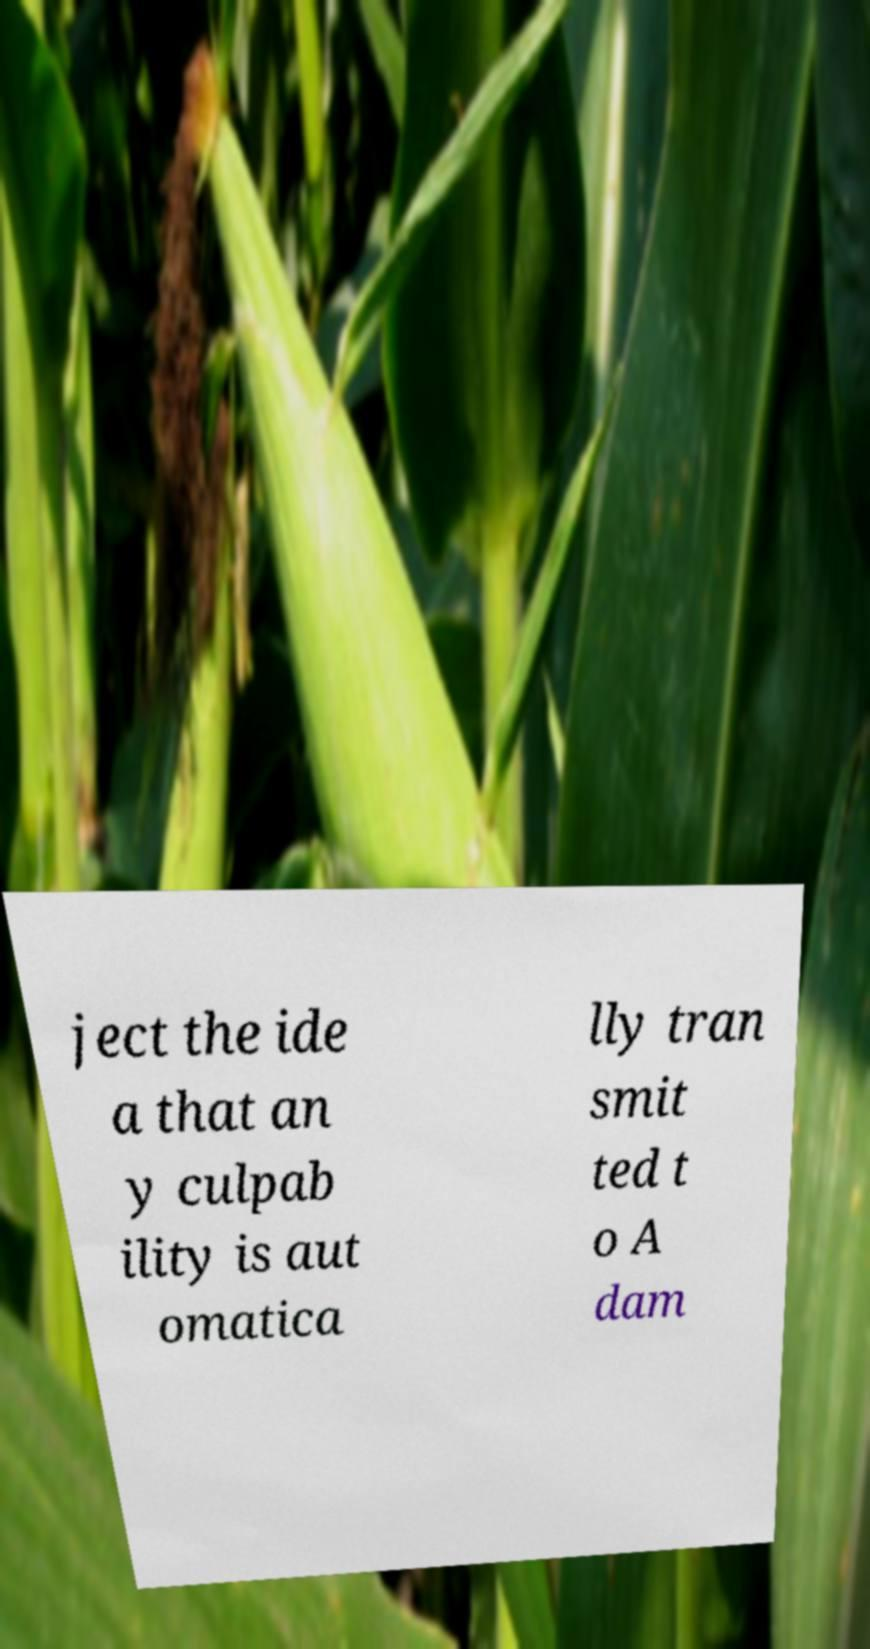Could you assist in decoding the text presented in this image and type it out clearly? ject the ide a that an y culpab ility is aut omatica lly tran smit ted t o A dam 